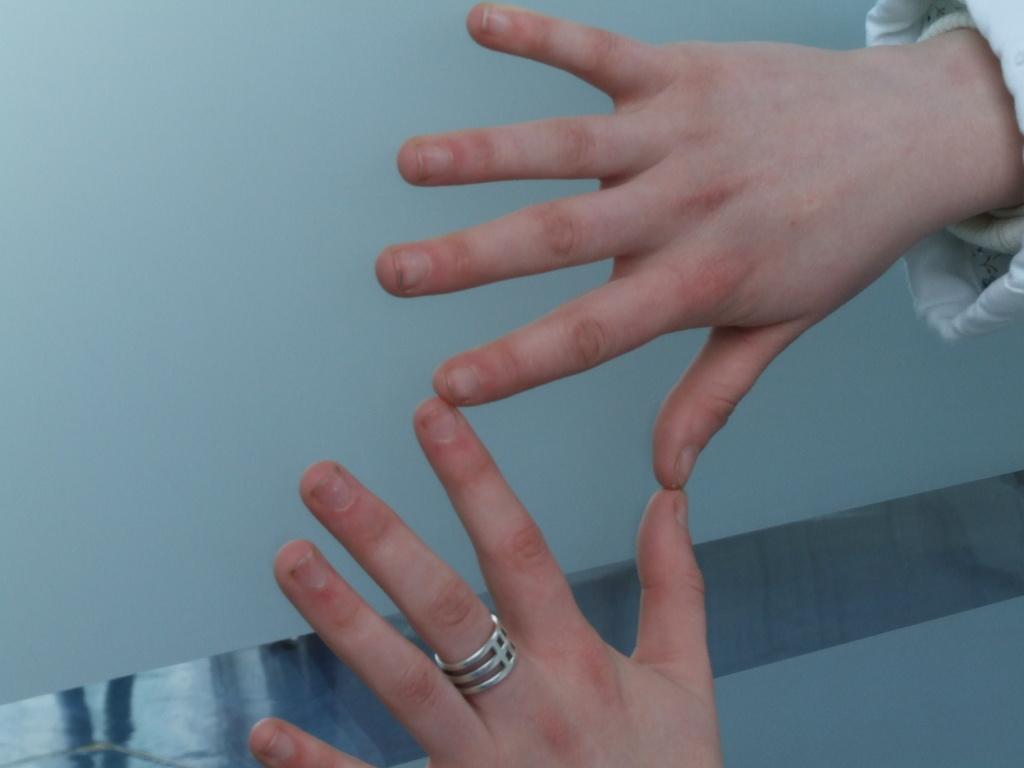Can you describe this image briefly? In this image I can see the person's hands who is wearing white dress. I can see a silver colored ring to his finger. In the background I can see the wall. 